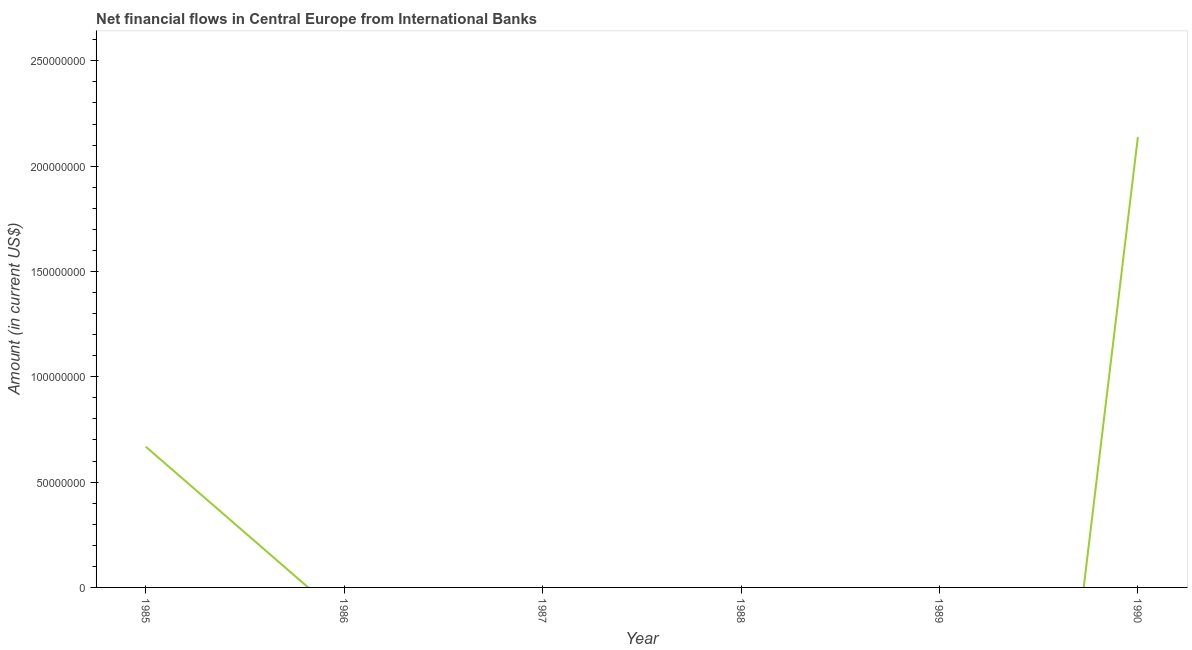What is the net financial flows from ibrd in 1986?
Your response must be concise. 0. Across all years, what is the maximum net financial flows from ibrd?
Your response must be concise. 2.14e+08. In which year was the net financial flows from ibrd maximum?
Your answer should be compact. 1990. What is the sum of the net financial flows from ibrd?
Your response must be concise. 2.81e+08. What is the average net financial flows from ibrd per year?
Give a very brief answer. 4.68e+07. What is the median net financial flows from ibrd?
Provide a succinct answer. 0. In how many years, is the net financial flows from ibrd greater than 20000000 US$?
Your response must be concise. 2. What is the difference between the highest and the lowest net financial flows from ibrd?
Ensure brevity in your answer.  2.14e+08. In how many years, is the net financial flows from ibrd greater than the average net financial flows from ibrd taken over all years?
Offer a terse response. 2. Does the net financial flows from ibrd monotonically increase over the years?
Provide a succinct answer. No. How many years are there in the graph?
Your response must be concise. 6. What is the difference between two consecutive major ticks on the Y-axis?
Provide a short and direct response. 5.00e+07. Are the values on the major ticks of Y-axis written in scientific E-notation?
Provide a short and direct response. No. Does the graph contain any zero values?
Offer a very short reply. Yes. Does the graph contain grids?
Make the answer very short. No. What is the title of the graph?
Keep it short and to the point. Net financial flows in Central Europe from International Banks. What is the label or title of the X-axis?
Your response must be concise. Year. What is the Amount (in current US$) of 1985?
Offer a very short reply. 6.68e+07. What is the Amount (in current US$) in 1986?
Your answer should be compact. 0. What is the Amount (in current US$) of 1988?
Ensure brevity in your answer.  0. What is the Amount (in current US$) in 1990?
Your response must be concise. 2.14e+08. What is the difference between the Amount (in current US$) in 1985 and 1990?
Make the answer very short. -1.47e+08. What is the ratio of the Amount (in current US$) in 1985 to that in 1990?
Provide a short and direct response. 0.31. 